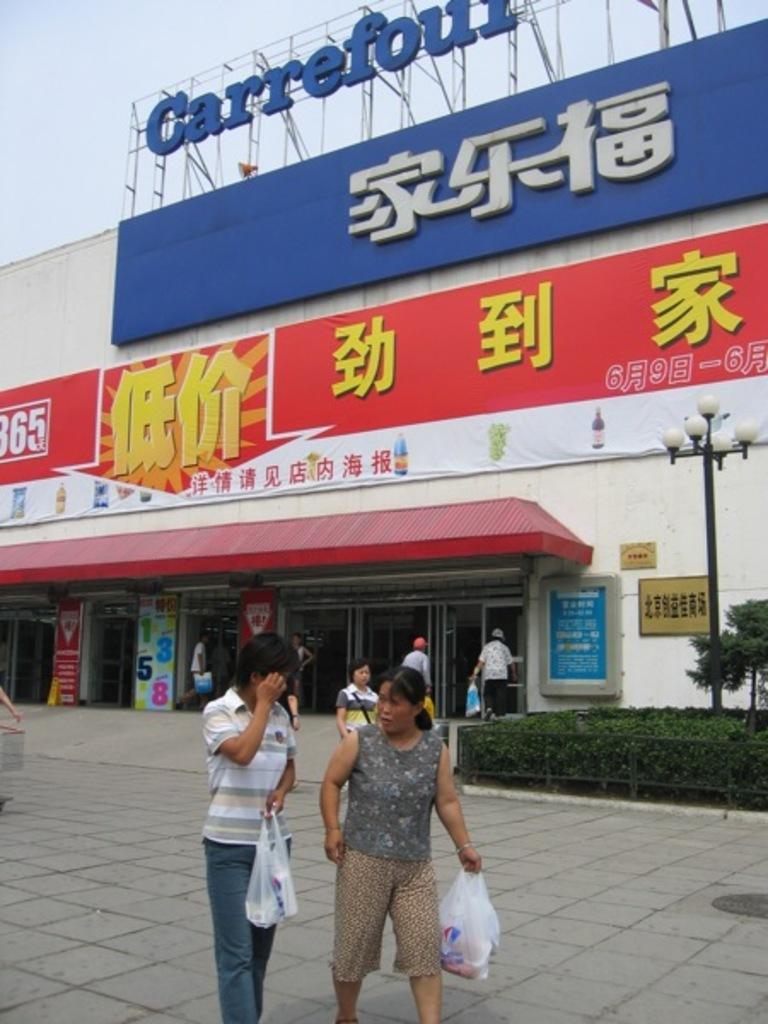In one or two sentences, can you explain what this image depicts? In this picture we can see two people, holding plastic bags with their hands, walking on the ground and at the back of them we can see some people, plants, posters, light pole, building, hoarding, some objects and in the background we can see the sky. 